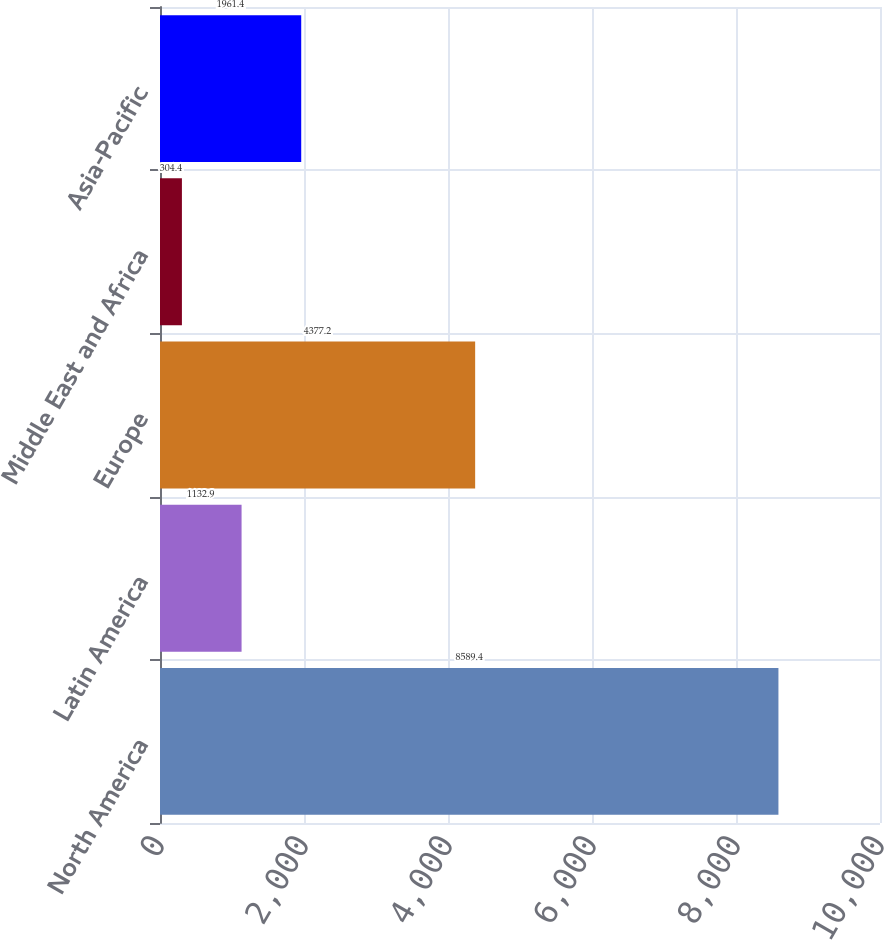Convert chart to OTSL. <chart><loc_0><loc_0><loc_500><loc_500><bar_chart><fcel>North America<fcel>Latin America<fcel>Europe<fcel>Middle East and Africa<fcel>Asia-Pacific<nl><fcel>8589.4<fcel>1132.9<fcel>4377.2<fcel>304.4<fcel>1961.4<nl></chart> 